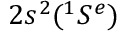<formula> <loc_0><loc_0><loc_500><loc_500>2 s ^ { 2 } ( ^ { 1 } { S ^ { e } } )</formula> 